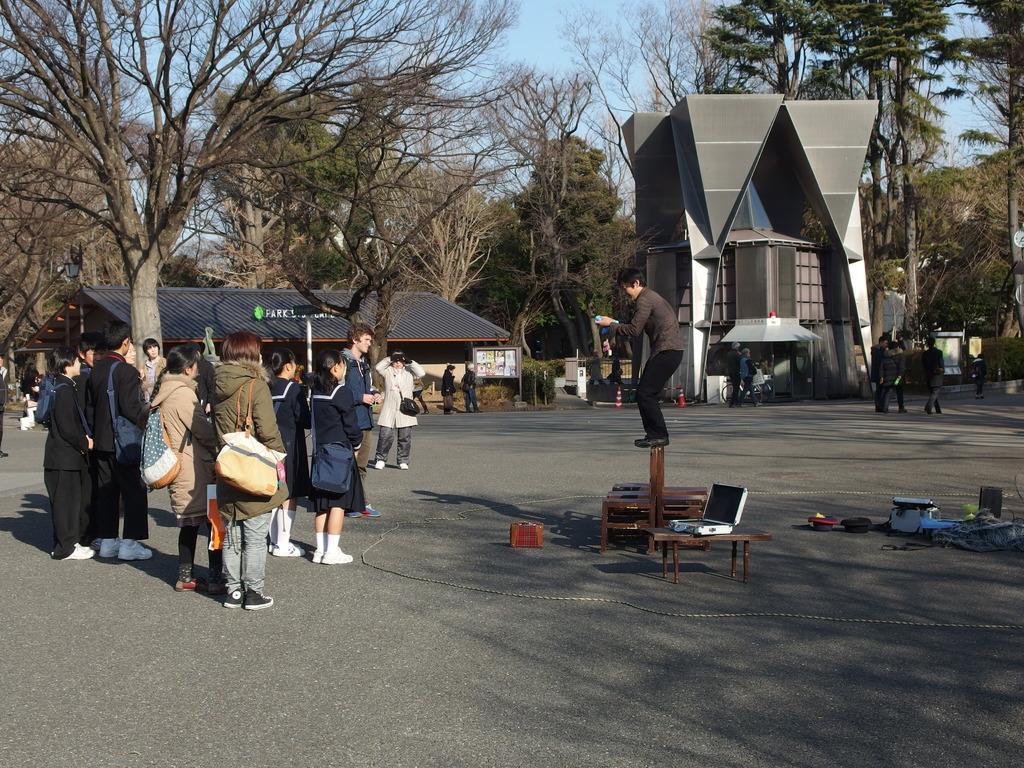Describe this image in one or two sentences. In the foreground of the picture we can see group of people, tables, box and various objects. Towards right we can see a person performing. In the middle of the picture there are trees, buildings, people and various objects. In the background it is sky. 